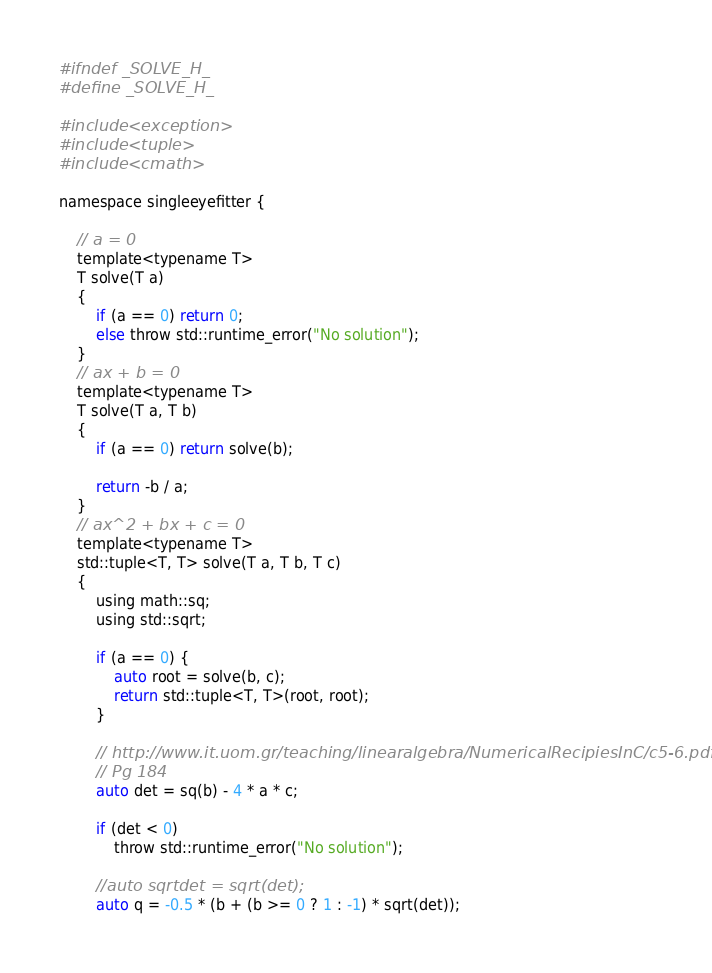Convert code to text. <code><loc_0><loc_0><loc_500><loc_500><_C_>#ifndef _SOLVE_H_
#define _SOLVE_H_

#include <exception>
#include <tuple>
#include <cmath>

namespace singleeyefitter {

    // a = 0
    template<typename T>
    T solve(T a)
    {
        if (a == 0) return 0;
        else throw std::runtime_error("No solution");
    }
    // ax + b = 0
    template<typename T>
    T solve(T a, T b)
    {
        if (a == 0) return solve(b);

        return -b / a;
    }
    // ax^2 + bx + c = 0
    template<typename T>
    std::tuple<T, T> solve(T a, T b, T c)
    {
        using math::sq;
        using std::sqrt;

        if (a == 0) {
            auto root = solve(b, c);
            return std::tuple<T, T>(root, root);
        }

        // http://www.it.uom.gr/teaching/linearalgebra/NumericalRecipiesInC/c5-6.pdf
        // Pg 184
        auto det = sq(b) - 4 * a * c;

        if (det < 0)
            throw std::runtime_error("No solution");

        //auto sqrtdet = sqrt(det);
        auto q = -0.5 * (b + (b >= 0 ? 1 : -1) * sqrt(det));</code> 